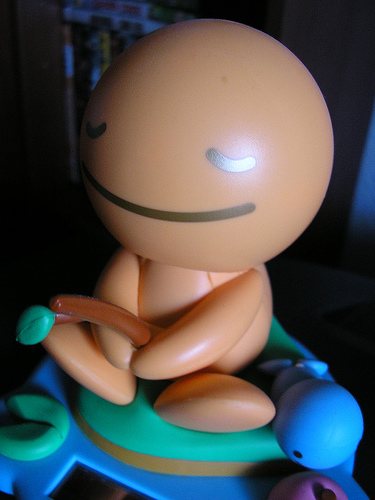<image>
Can you confirm if the doll is in front of the chair? No. The doll is not in front of the chair. The spatial positioning shows a different relationship between these objects. 